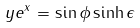Convert formula to latex. <formula><loc_0><loc_0><loc_500><loc_500>y e ^ { x } = \sin { \phi } \sinh { \epsilon }</formula> 